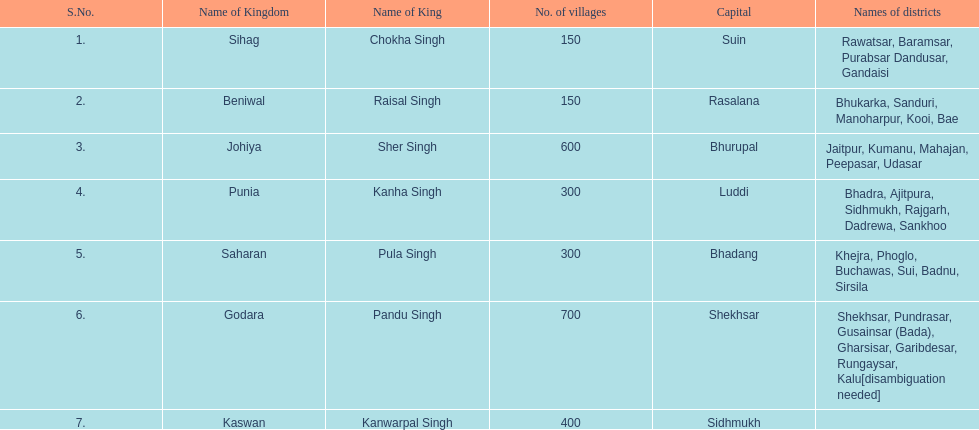Which kingdom has the most villages? Godara. 